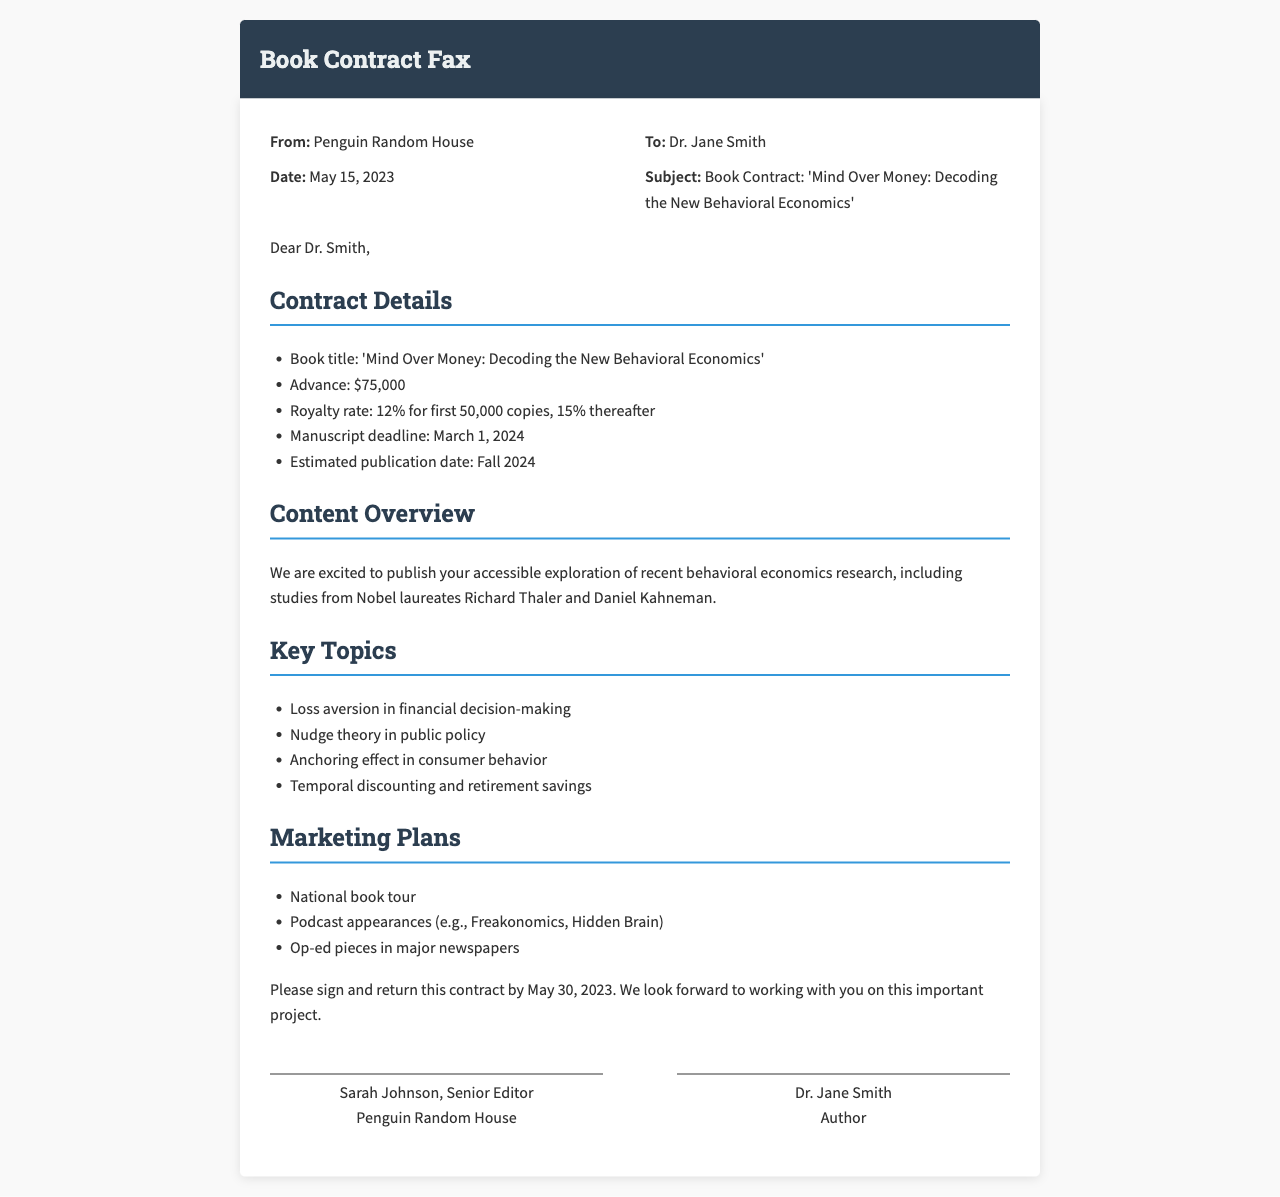What is the publisher's name? The publisher of the book is mentioned at the top of the document.
Answer: Penguin Random House What is the book title? The book title is specified in the subject line of the fax.
Answer: Mind Over Money: Decoding the New Behavioral Economics What is the advance payment? The advance payment is clearly stated in the contract details section.
Answer: $75,000 When is the manuscript deadline? The manuscript deadline is listed under the contract details.
Answer: March 1, 2024 What is the royalty rate for the first 50,000 copies? The royalty rate for the first 50,000 copies is mentioned in the contract details.
Answer: 12% What key topic relates to financial decision-making? A key topic is specified in the list of important topics within the content overview section.
Answer: Loss aversion in financial decision-making What marketing activity involves traveling? The marketing plans include activities that involve traveling for promotion of the book.
Answer: National book tour Who is the senior editor? The name of the senior editor is provided at the bottom of the document.
Answer: Sarah Johnson By when should the contract be returned? The deadline for returning the signed contract is indicated in the final paragraph.
Answer: May 30, 2023 